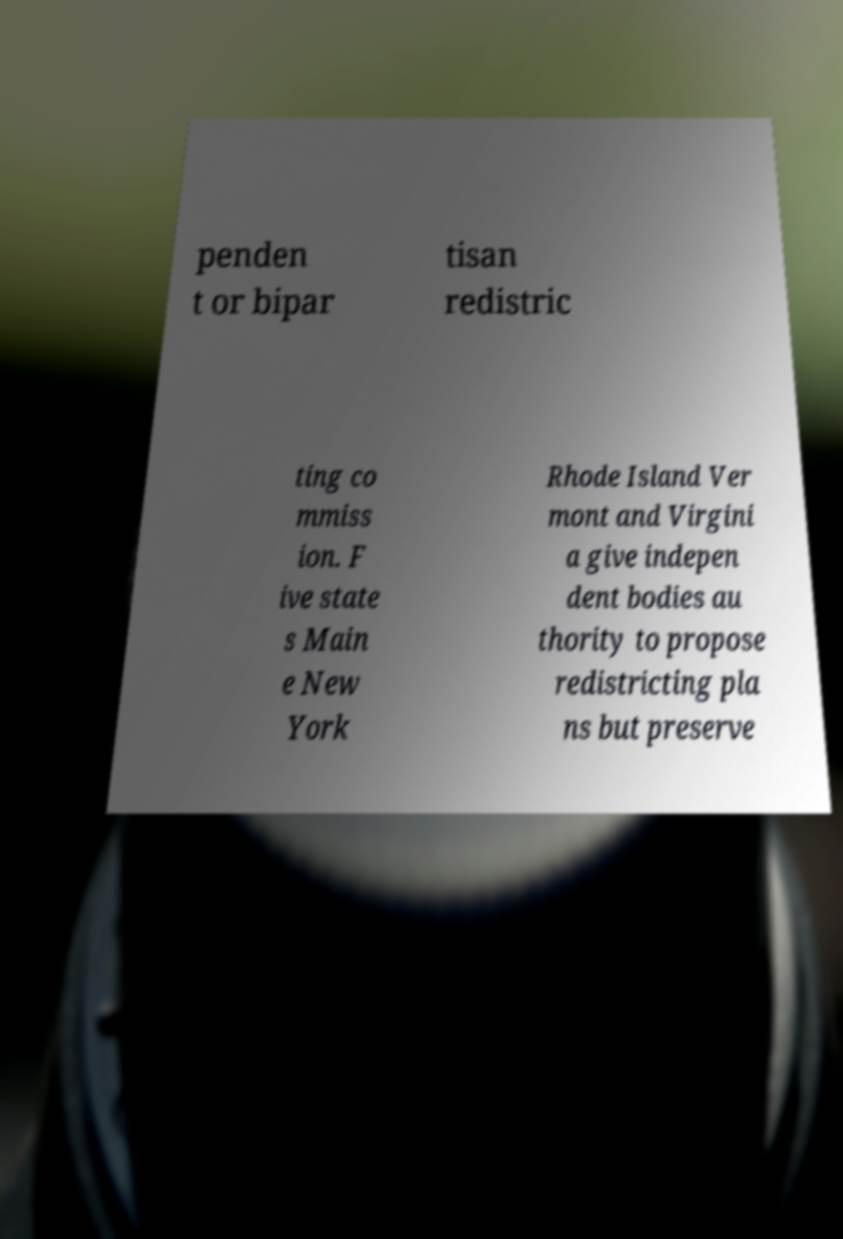Please identify and transcribe the text found in this image. penden t or bipar tisan redistric ting co mmiss ion. F ive state s Main e New York Rhode Island Ver mont and Virgini a give indepen dent bodies au thority to propose redistricting pla ns but preserve 